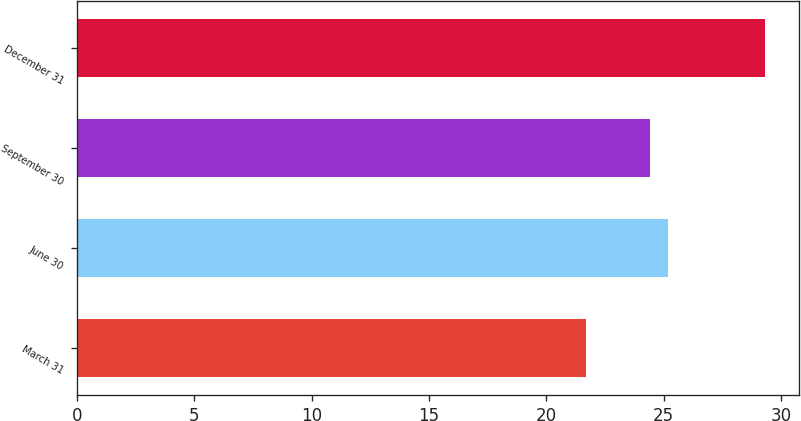Convert chart. <chart><loc_0><loc_0><loc_500><loc_500><bar_chart><fcel>March 31<fcel>June 30<fcel>September 30<fcel>December 31<nl><fcel>21.7<fcel>25.16<fcel>24.4<fcel>29.3<nl></chart> 